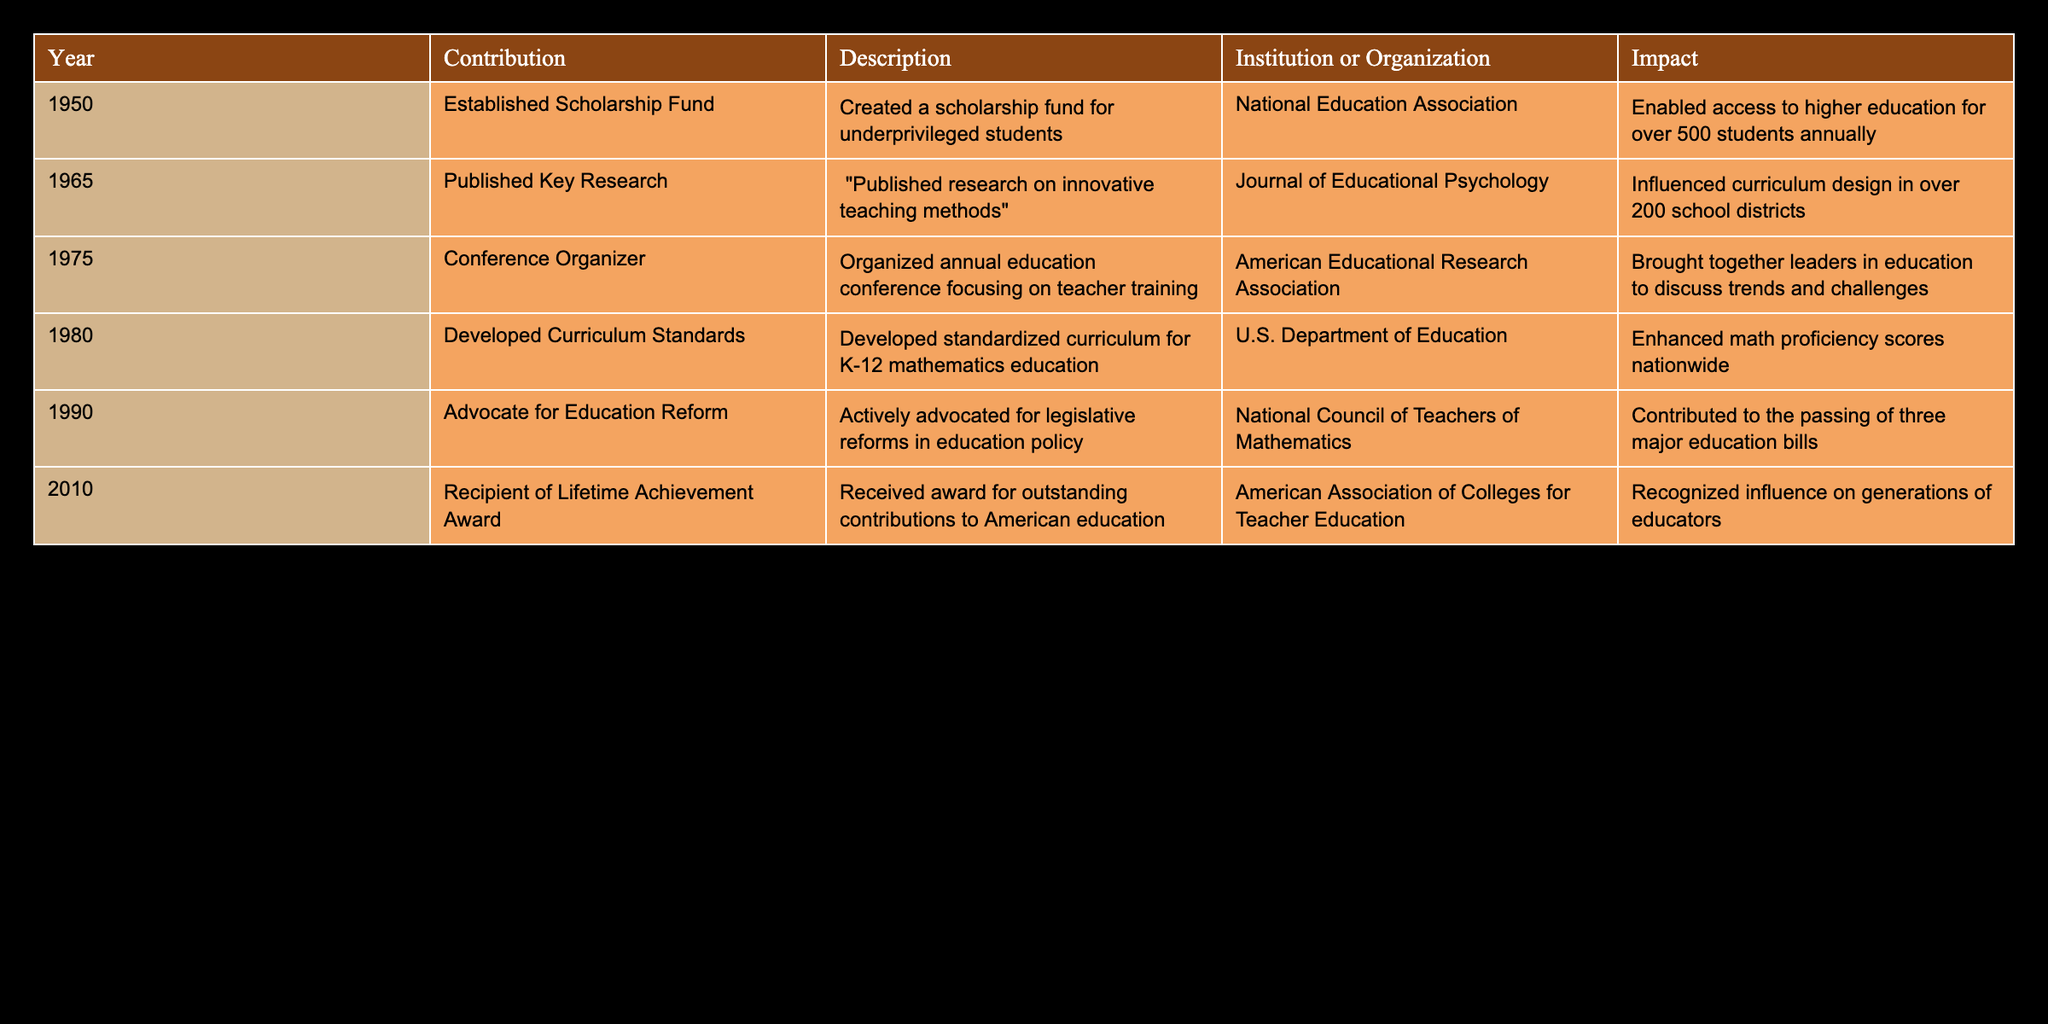What year did Merrill H. Werts establish the Scholarship Fund? Referring to the table, the Scholarship Fund was established in 1950, as stated in the first row under the Year column.
Answer: 1950 Which organization received the Lifetime Achievement Award for Merrill H. Werts? The award was given by the American Association of Colleges for Teacher Education, as indicated in the last row of the table under the Institution or Organization column.
Answer: American Association of Colleges for Teacher Education How many contributions did Merrill H. Werts make in the 1980s? The contributions from the 1980s listed in the table are: 'Developed Curriculum Standards' in 1980. There is only one entry for that decade.
Answer: 1 Was the research published in 1965 related to innovative teaching methods? Yes, the contribution in 1965 involved publishing research on innovative teaching methods, which confirms that the statement is true.
Answer: Yes What impact did the establishment of the Scholarship Fund have on students? According to the Description column, the Scholarship Fund enabled access to higher education for over 500 students annually, reflecting the significant impact on educational opportunities.
Answer: Enabled access for over 500 students annually What were the total years listed when Merrill H. Werts was active in education contributions according to the table? The years listed are 1950, 1965, 1975, 1980, 1990, and 2010. Counting these gives a total of 6 years of contributions.
Answer: 6 Which contribution had the greatest impact according to the table? The contribution regarding the 'Established Scholarship Fund' realistically influences over 500 students annually, which is significant compared to the impacts of other contributions.
Answer: Established Scholarship Fund Did Merrill H. Werts develop curriculum standards before 1980? According to the table, the 'Developed Curriculum Standards' contribution took place in 1980. Thus, the answer to this question is no, as there are no contributions listed before 1980 that mention developing curriculum standards.
Answer: No 